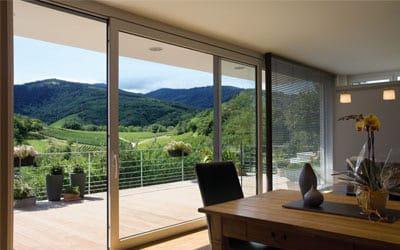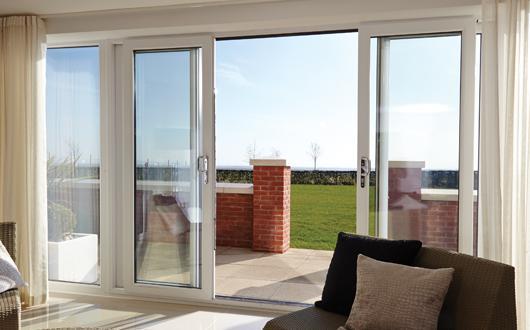The first image is the image on the left, the second image is the image on the right. Assess this claim about the two images: "The doors are open in both images.". Correct or not? Answer yes or no. Yes. 